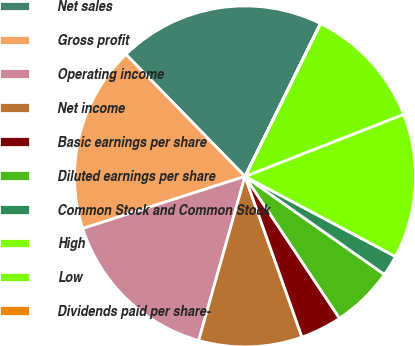Convert chart. <chart><loc_0><loc_0><loc_500><loc_500><pie_chart><fcel>Net sales<fcel>Gross profit<fcel>Operating income<fcel>Net income<fcel>Basic earnings per share<fcel>Diluted earnings per share<fcel>Common Stock and Common Stock<fcel>High<fcel>Low<fcel>Dividends paid per share-<nl><fcel>19.6%<fcel>17.64%<fcel>15.68%<fcel>9.8%<fcel>3.93%<fcel>5.89%<fcel>1.97%<fcel>13.72%<fcel>11.76%<fcel>0.01%<nl></chart> 